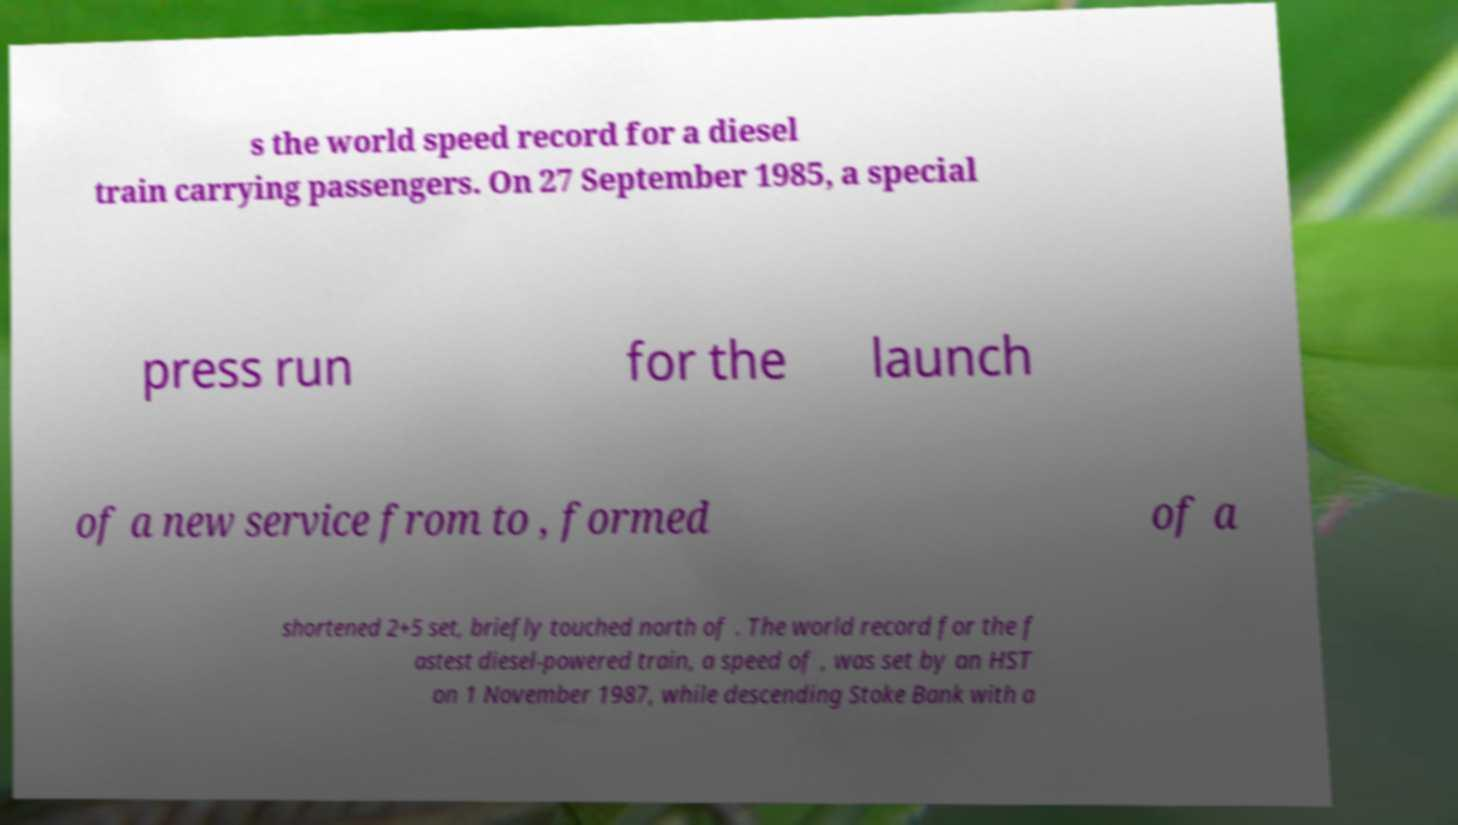Could you assist in decoding the text presented in this image and type it out clearly? s the world speed record for a diesel train carrying passengers. On 27 September 1985, a special press run for the launch of a new service from to , formed of a shortened 2+5 set, briefly touched north of . The world record for the f astest diesel-powered train, a speed of , was set by an HST on 1 November 1987, while descending Stoke Bank with a 